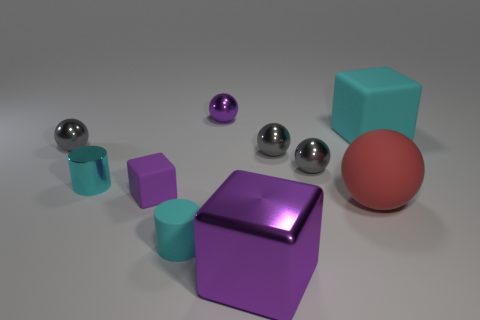How big is the cyan matte object on the left side of the matte object that is to the right of the rubber sphere that is behind the big purple thing?
Keep it short and to the point. Small. There is a purple object that is the same shape as the big red rubber object; what size is it?
Your answer should be very brief. Small. What number of big things are either rubber cylinders or cyan blocks?
Offer a terse response. 1. Are the gray thing that is on the left side of the cyan metal cylinder and the purple thing on the right side of the purple ball made of the same material?
Provide a short and direct response. Yes. What material is the gray object that is to the left of the small purple ball?
Your answer should be compact. Metal. How many shiny objects are either tiny cyan cylinders or tiny objects?
Keep it short and to the point. 5. There is a large thing that is behind the tiny gray metal thing to the left of the purple sphere; what is its color?
Your answer should be very brief. Cyan. Are the big red sphere and the large cube that is behind the big shiny block made of the same material?
Your response must be concise. Yes. What color is the rubber ball that is behind the small cyan thing that is to the right of the cyan cylinder behind the cyan matte cylinder?
Make the answer very short. Red. Are there any other things that have the same shape as the purple rubber object?
Make the answer very short. Yes. 